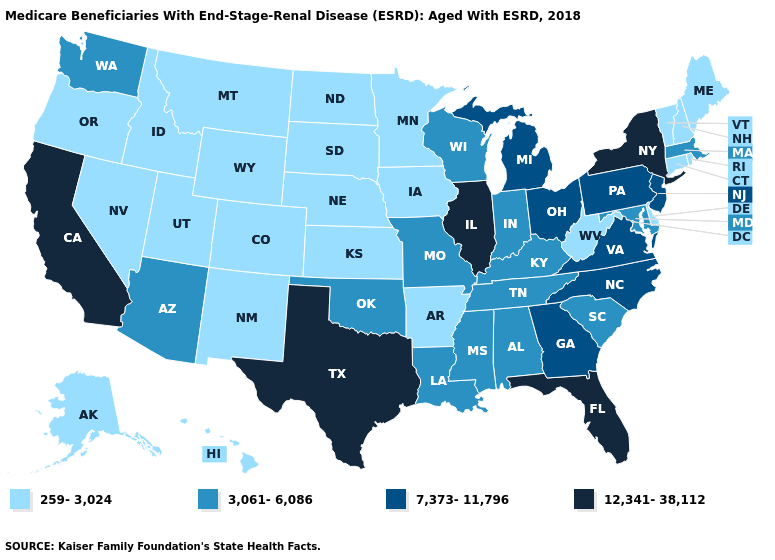Name the states that have a value in the range 7,373-11,796?
Answer briefly. Georgia, Michigan, New Jersey, North Carolina, Ohio, Pennsylvania, Virginia. What is the value of Iowa?
Concise answer only. 259-3,024. Name the states that have a value in the range 259-3,024?
Short answer required. Alaska, Arkansas, Colorado, Connecticut, Delaware, Hawaii, Idaho, Iowa, Kansas, Maine, Minnesota, Montana, Nebraska, Nevada, New Hampshire, New Mexico, North Dakota, Oregon, Rhode Island, South Dakota, Utah, Vermont, West Virginia, Wyoming. What is the value of Colorado?
Concise answer only. 259-3,024. Does Oklahoma have a higher value than Georgia?
Quick response, please. No. Which states have the lowest value in the USA?
Quick response, please. Alaska, Arkansas, Colorado, Connecticut, Delaware, Hawaii, Idaho, Iowa, Kansas, Maine, Minnesota, Montana, Nebraska, Nevada, New Hampshire, New Mexico, North Dakota, Oregon, Rhode Island, South Dakota, Utah, Vermont, West Virginia, Wyoming. Among the states that border Nevada , which have the lowest value?
Concise answer only. Idaho, Oregon, Utah. Name the states that have a value in the range 3,061-6,086?
Concise answer only. Alabama, Arizona, Indiana, Kentucky, Louisiana, Maryland, Massachusetts, Mississippi, Missouri, Oklahoma, South Carolina, Tennessee, Washington, Wisconsin. Among the states that border Tennessee , does Mississippi have the highest value?
Concise answer only. No. What is the value of Tennessee?
Be succinct. 3,061-6,086. Which states have the lowest value in the USA?
Write a very short answer. Alaska, Arkansas, Colorado, Connecticut, Delaware, Hawaii, Idaho, Iowa, Kansas, Maine, Minnesota, Montana, Nebraska, Nevada, New Hampshire, New Mexico, North Dakota, Oregon, Rhode Island, South Dakota, Utah, Vermont, West Virginia, Wyoming. Does the map have missing data?
Short answer required. No. What is the lowest value in states that border Kansas?
Answer briefly. 259-3,024. Does Idaho have the highest value in the USA?
Short answer required. No. 